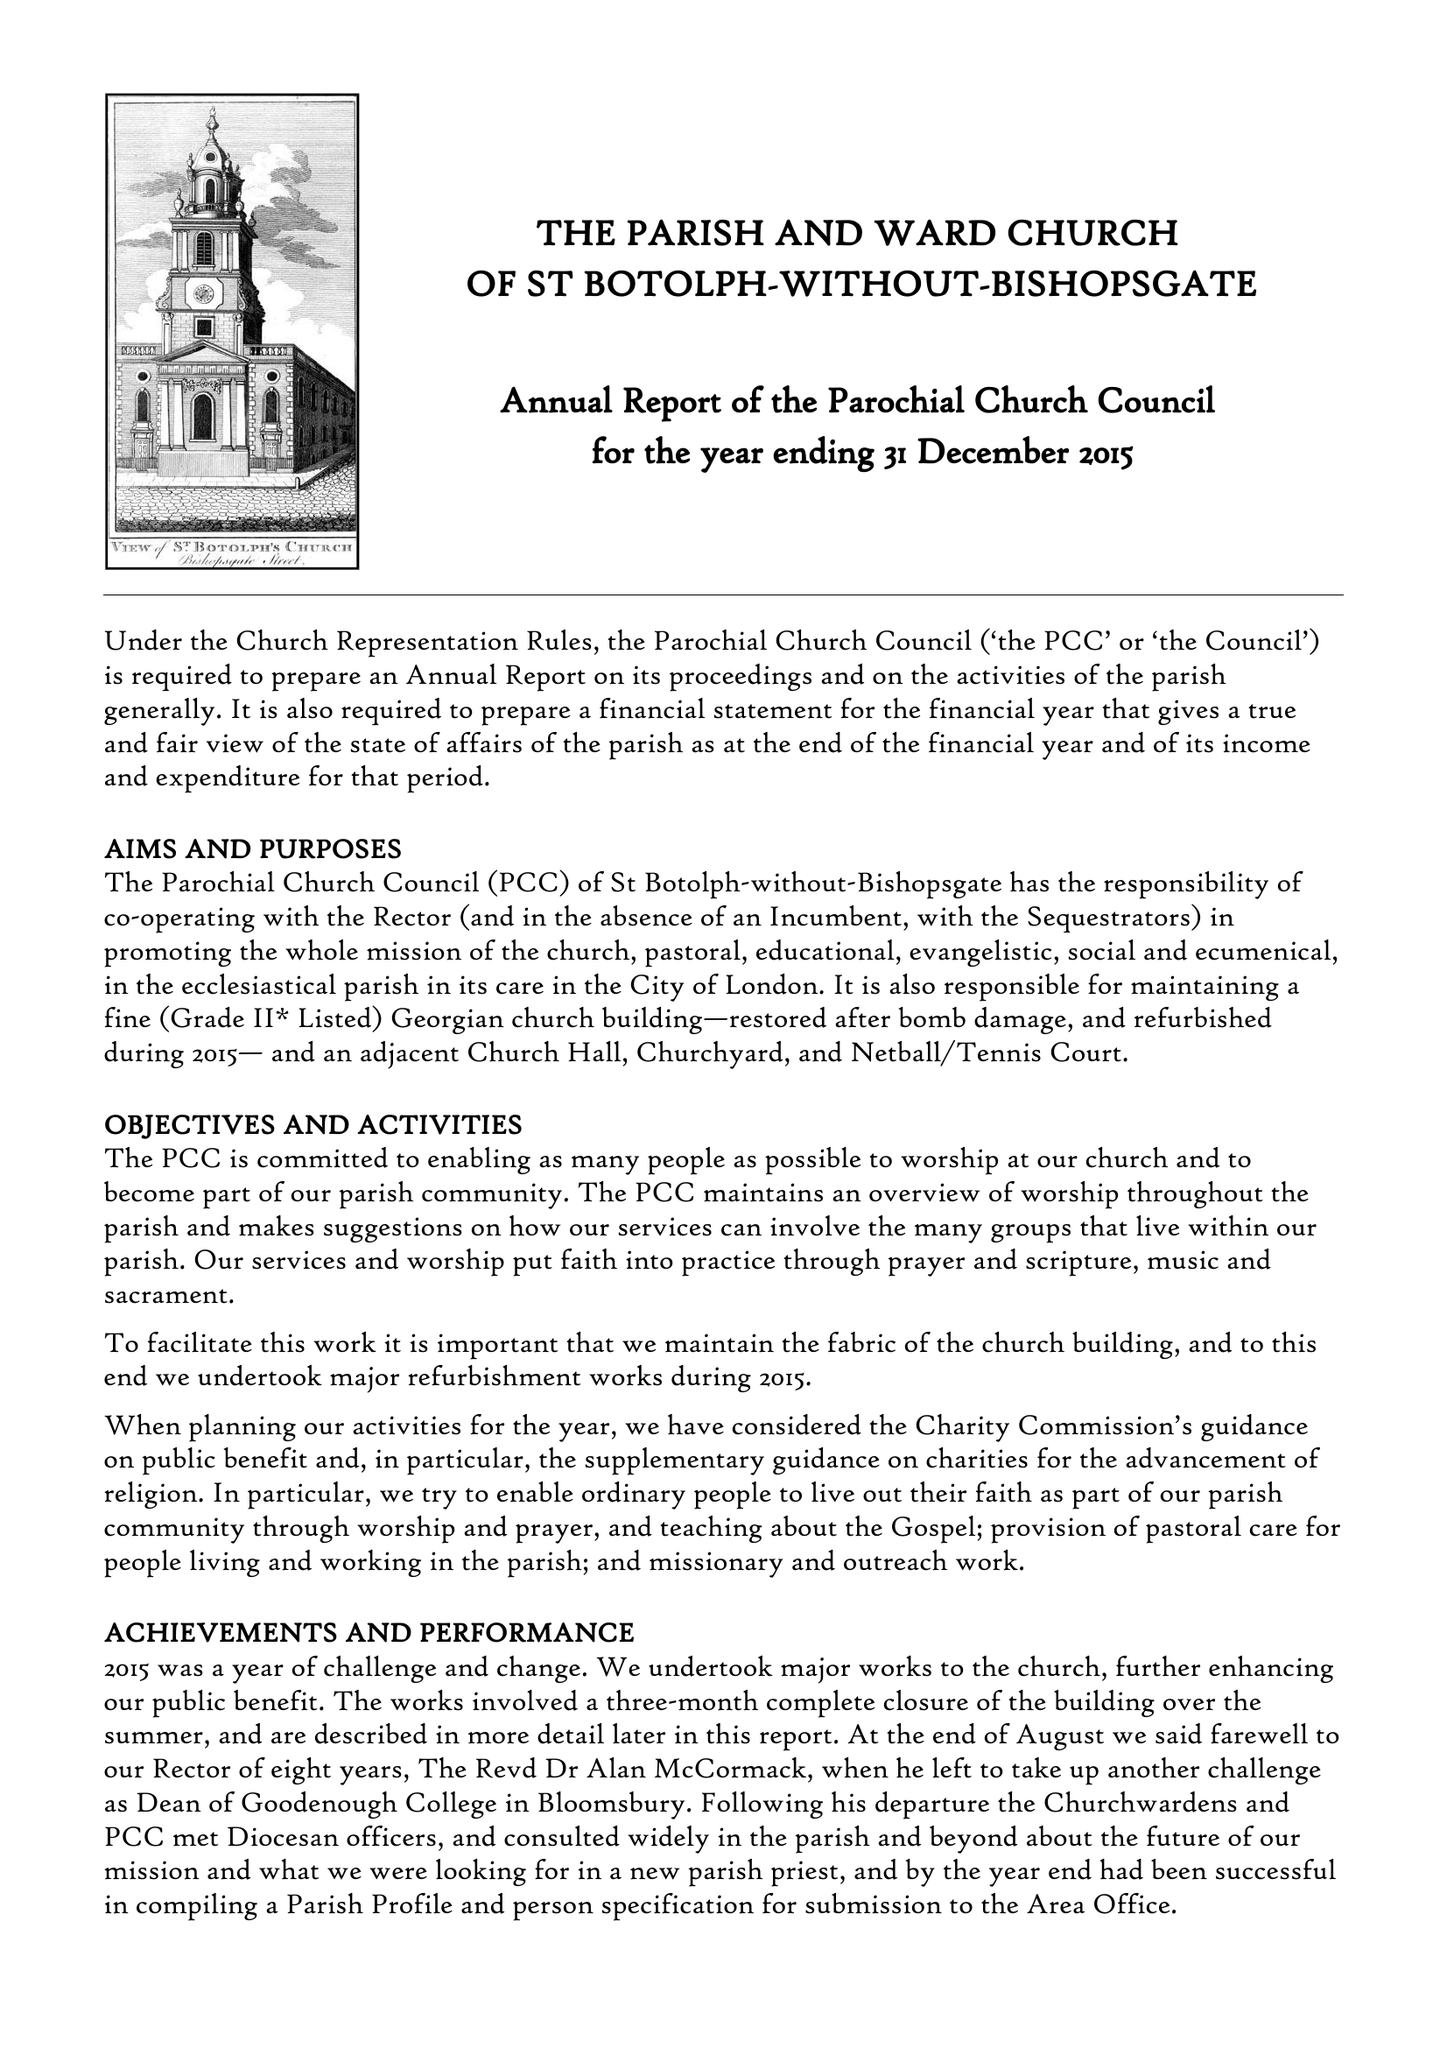What is the value for the charity_number?
Answer the question using a single word or phrase. 1135985 